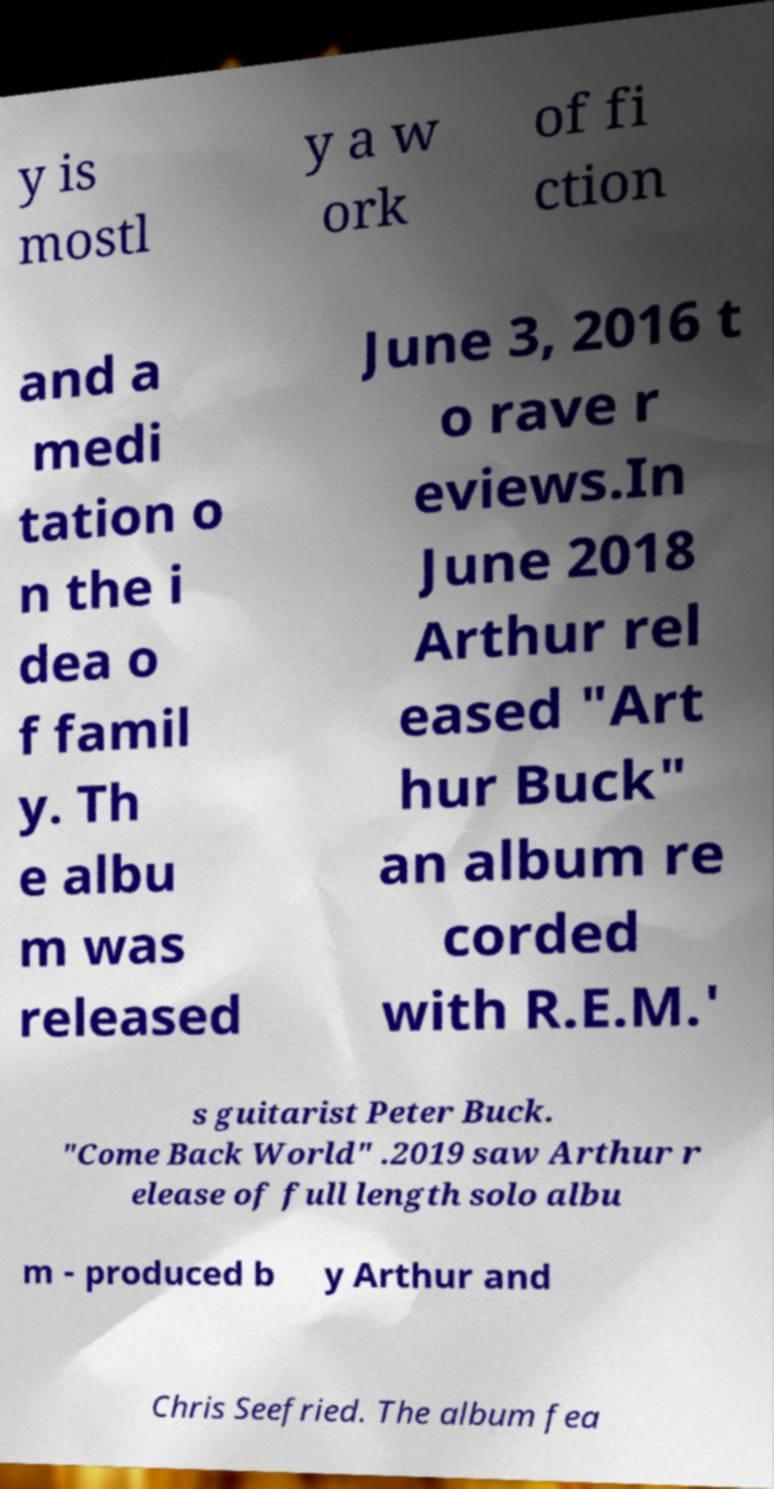Could you extract and type out the text from this image? y is mostl y a w ork of fi ction and a medi tation o n the i dea o f famil y. Th e albu m was released June 3, 2016 t o rave r eviews.In June 2018 Arthur rel eased "Art hur Buck" an album re corded with R.E.M.' s guitarist Peter Buck. "Come Back World" .2019 saw Arthur r elease of full length solo albu m - produced b y Arthur and Chris Seefried. The album fea 